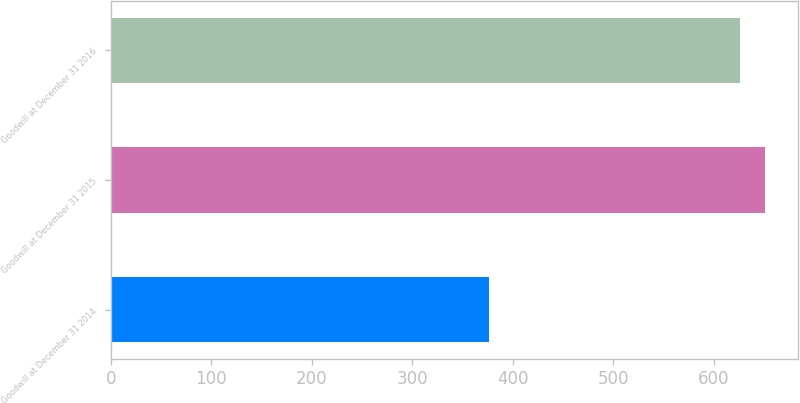<chart> <loc_0><loc_0><loc_500><loc_500><bar_chart><fcel>Goodwill at December 31 2014<fcel>Goodwill at December 31 2015<fcel>Goodwill at December 31 2016<nl><fcel>376<fcel>651.33<fcel>626.1<nl></chart> 